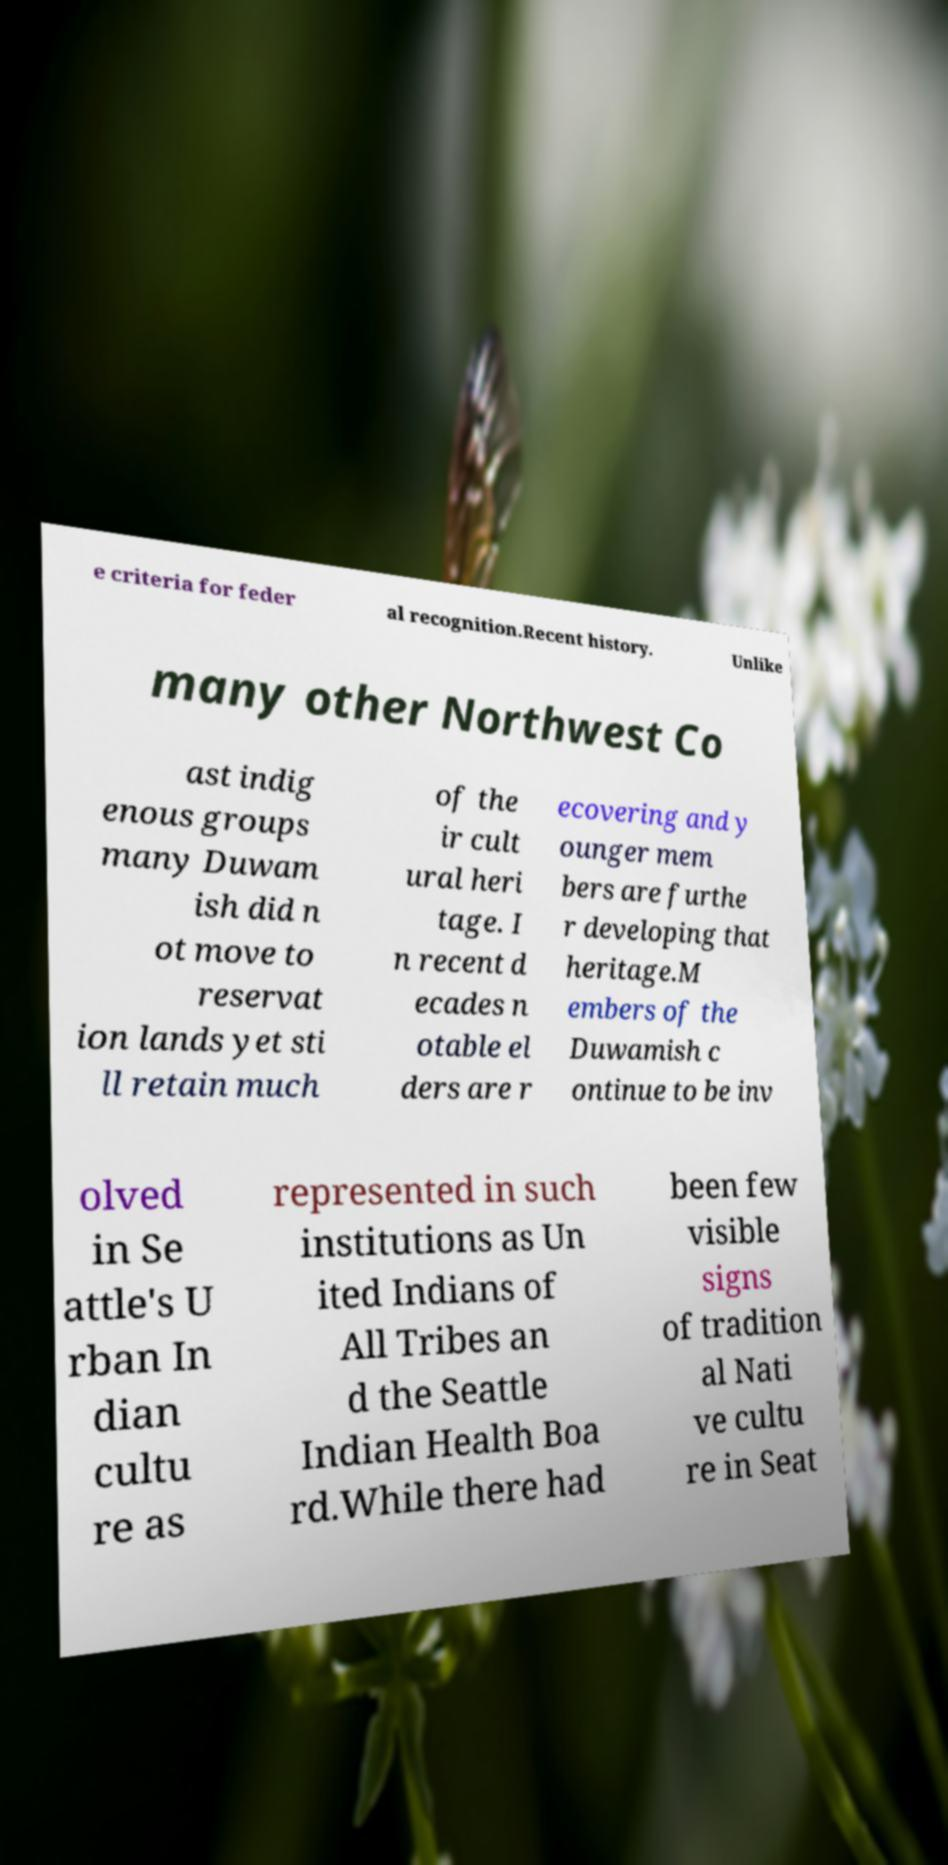For documentation purposes, I need the text within this image transcribed. Could you provide that? e criteria for feder al recognition.Recent history. Unlike many other Northwest Co ast indig enous groups many Duwam ish did n ot move to reservat ion lands yet sti ll retain much of the ir cult ural heri tage. I n recent d ecades n otable el ders are r ecovering and y ounger mem bers are furthe r developing that heritage.M embers of the Duwamish c ontinue to be inv olved in Se attle's U rban In dian cultu re as represented in such institutions as Un ited Indians of All Tribes an d the Seattle Indian Health Boa rd.While there had been few visible signs of tradition al Nati ve cultu re in Seat 